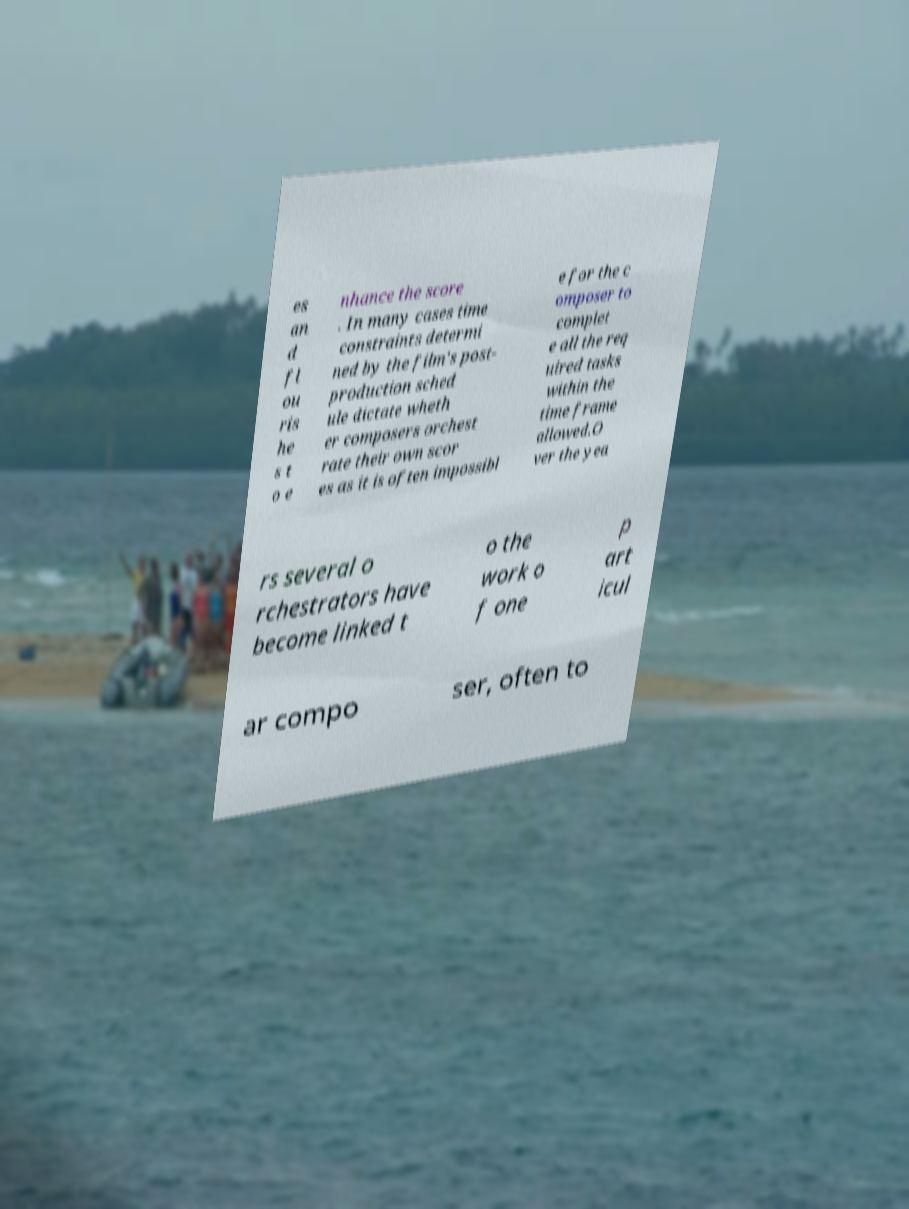Can you read and provide the text displayed in the image?This photo seems to have some interesting text. Can you extract and type it out for me? es an d fl ou ris he s t o e nhance the score . In many cases time constraints determi ned by the film's post- production sched ule dictate wheth er composers orchest rate their own scor es as it is often impossibl e for the c omposer to complet e all the req uired tasks within the time frame allowed.O ver the yea rs several o rchestrators have become linked t o the work o f one p art icul ar compo ser, often to 